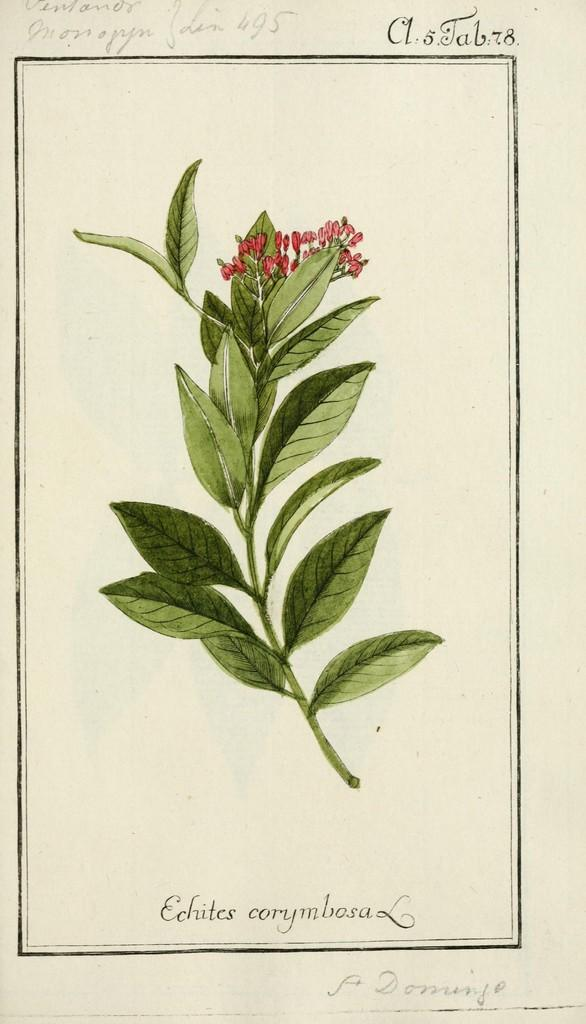What type of plant life is visible in the image? There are flowers and leaves in the image. Are the flowers and leaves connected to each other in the image? Yes, the flowers and leaves are on a stem in the image. How many frogs can be seen sitting on the oatmeal in the image? There is no oatmeal or frogs present in the image; it features flowers and leaves on a stem. 